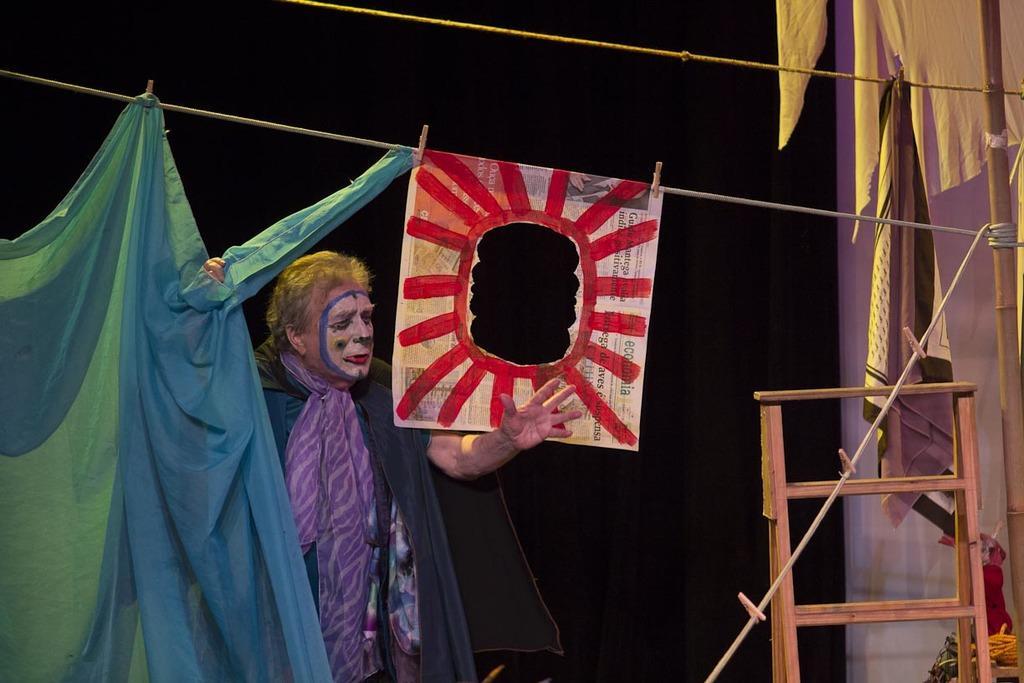Could you give a brief overview of what you see in this image? In this image I can see a person standing and wearing different costume. I can see a red and white color paper and blue cover attached to the rope. Background is in black color and I can see a ladder and few objects. 